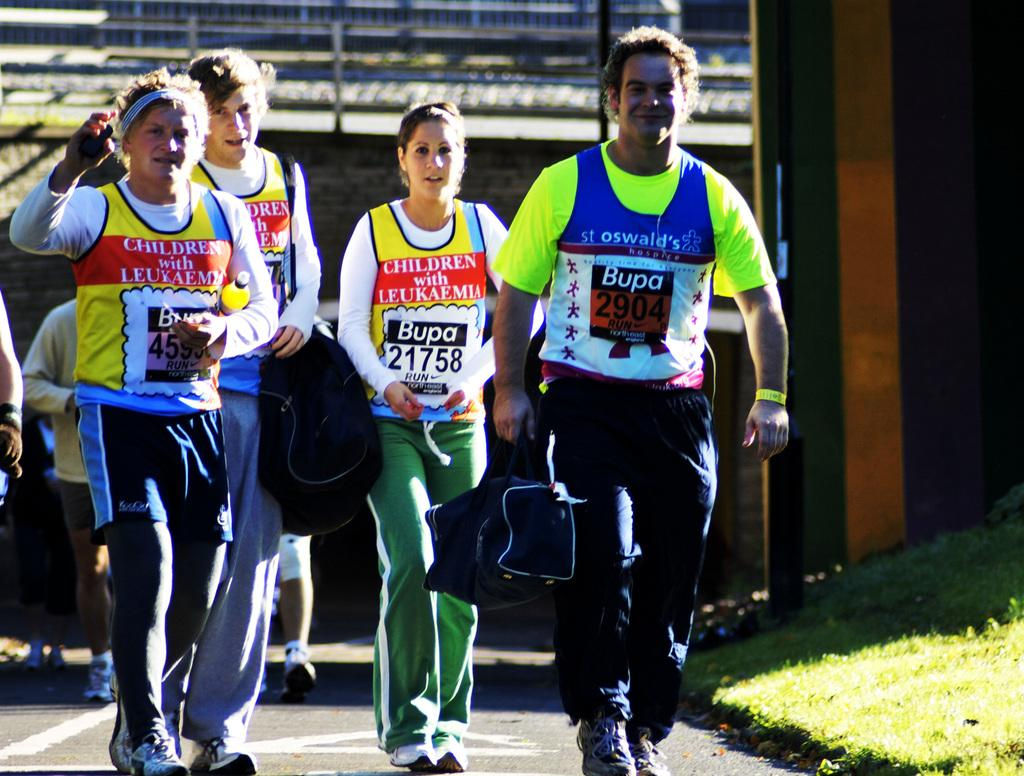<image>
Describe the image concisely. A person is on the street with the number 21758 on their shirt. 